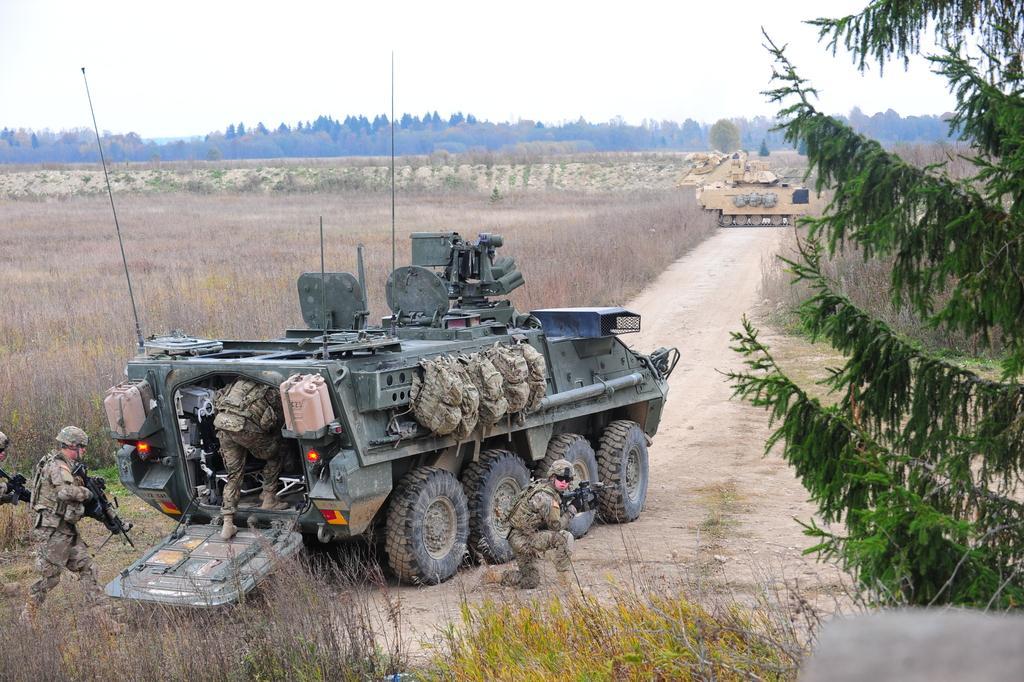How would you summarize this image in a sentence or two? In this picture we can see the military tank moving on the ground with some military men. Behind we can see the dry grass and some trees. In the front bottom right corner we can see the tree. 